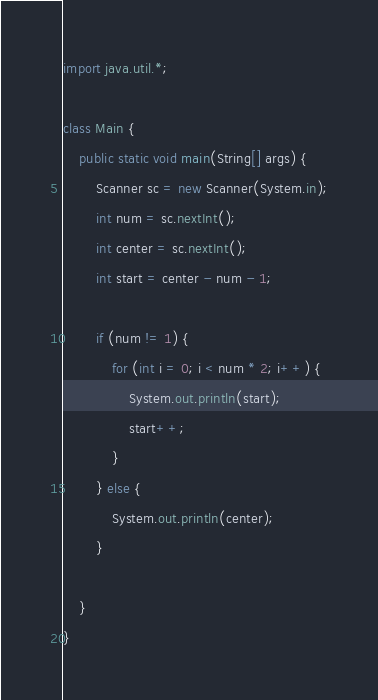<code> <loc_0><loc_0><loc_500><loc_500><_Java_>import java.util.*;

class Main {
	public static void main(String[] args) {
		Scanner sc = new Scanner(System.in);
		int num = sc.nextInt();
		int center = sc.nextInt();
		int start = center - num - 1;

		if (num != 1) {
			for (int i = 0; i < num * 2; i++) {
				System.out.println(start);
				start++;
			}
		} else {
			System.out.println(center);
		}

	}
}</code> 